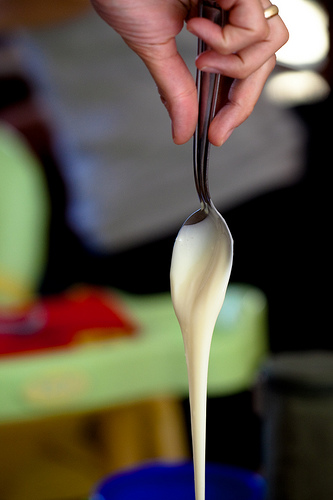<image>
Is there a batter on the spoon? Yes. Looking at the image, I can see the batter is positioned on top of the spoon, with the spoon providing support. 